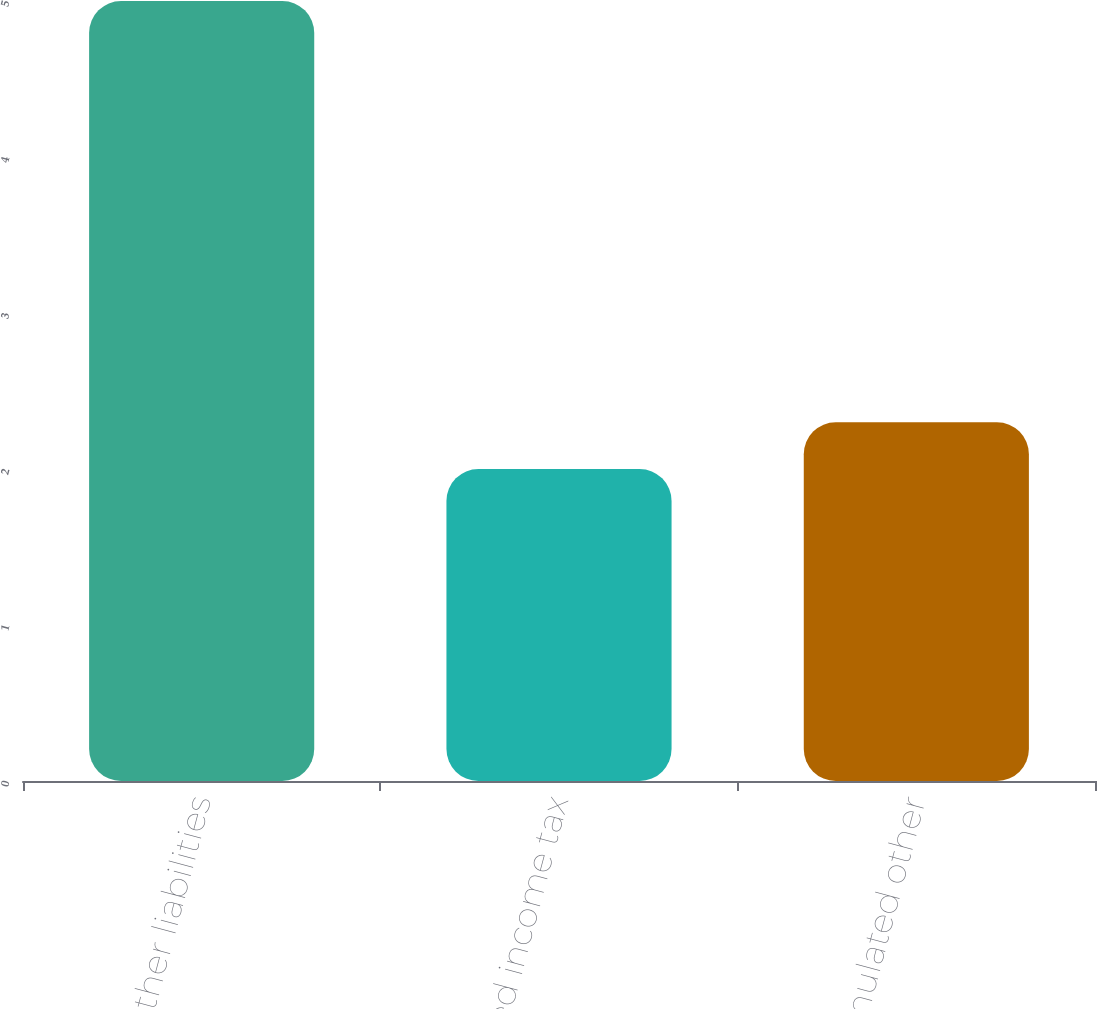Convert chart to OTSL. <chart><loc_0><loc_0><loc_500><loc_500><bar_chart><fcel>Other liabilities<fcel>Deferred income tax<fcel>Accumulated other<nl><fcel>5<fcel>2<fcel>2.3<nl></chart> 